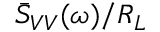<formula> <loc_0><loc_0><loc_500><loc_500>\ B a r { S } _ { V V } ( \omega ) / R _ { L }</formula> 